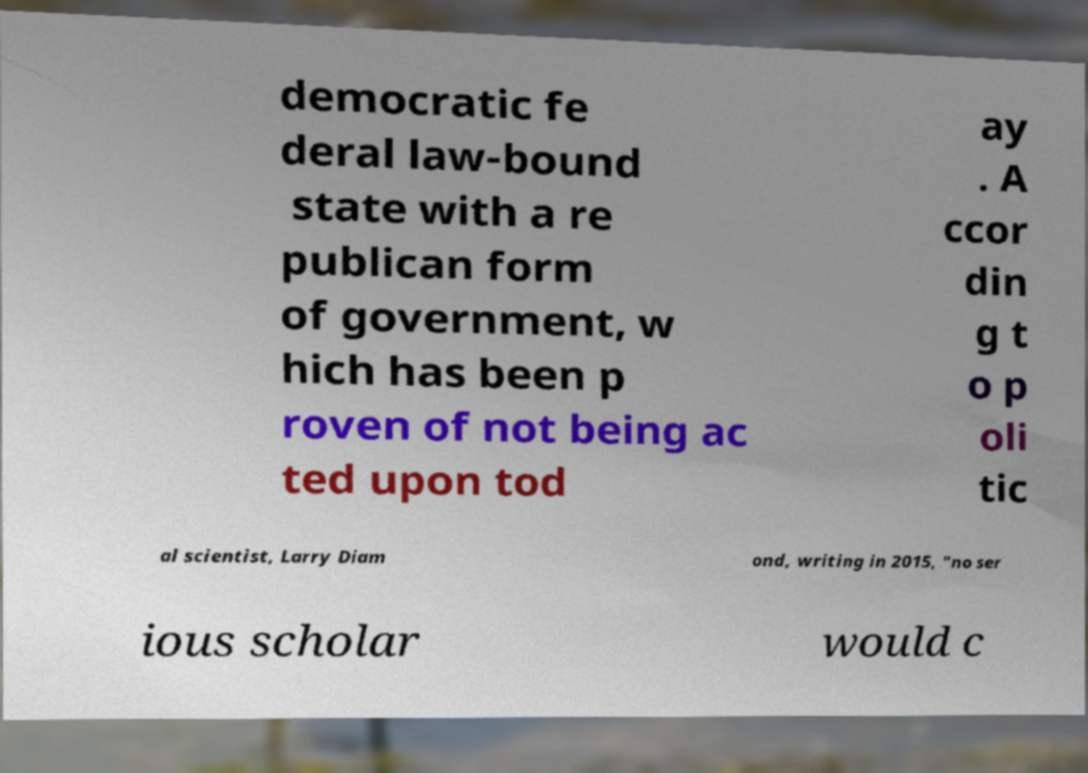I need the written content from this picture converted into text. Can you do that? democratic fe deral law-bound state with a re publican form of government, w hich has been p roven of not being ac ted upon tod ay . A ccor din g t o p oli tic al scientist, Larry Diam ond, writing in 2015, "no ser ious scholar would c 